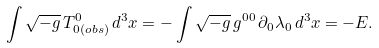<formula> <loc_0><loc_0><loc_500><loc_500>\int \sqrt { - g } \, T _ { 0 ( o b s ) } ^ { 0 } \, d ^ { 3 } x = - \int \sqrt { - g } \, g ^ { 0 0 } \, \partial _ { 0 } \lambda _ { 0 } \, d ^ { 3 } x = - E .</formula> 